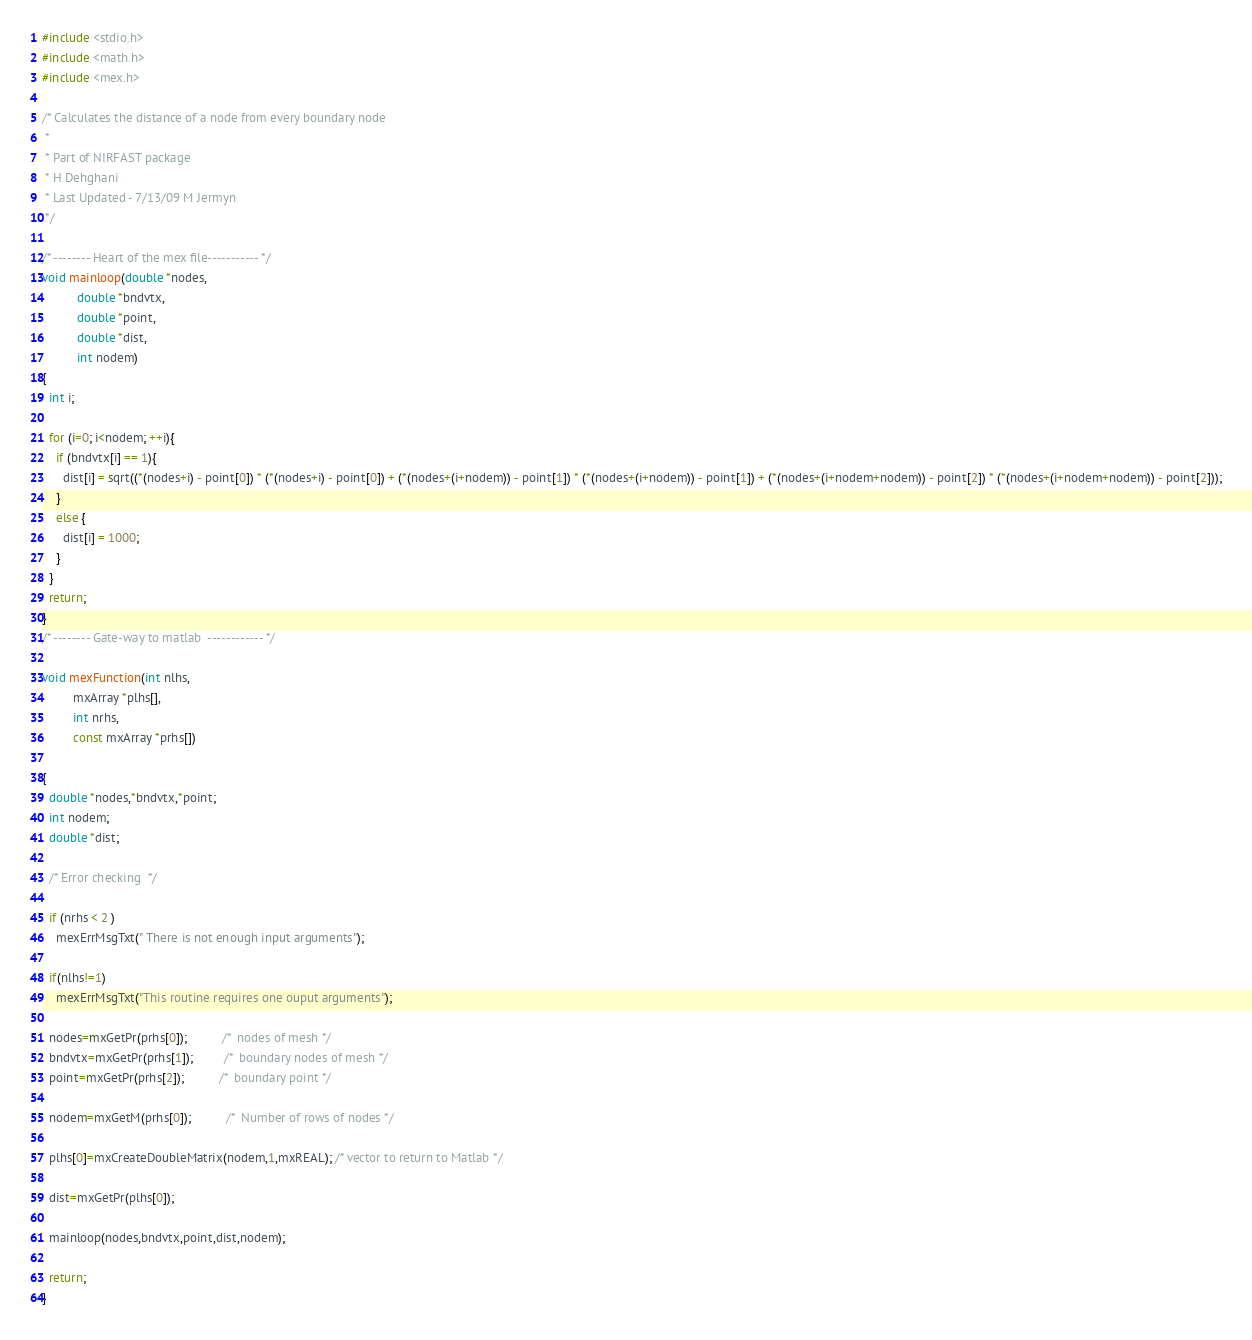Convert code to text. <code><loc_0><loc_0><loc_500><loc_500><_C_>#include <stdio.h>
#include <math.h>
#include <mex.h>

/* Calculates the distance of a node from every boundary node
 *
 * Part of NIRFAST package
 * H Dehghani
 * Last Updated - 7/13/09 M Jermyn
 */

/* -------- Heart of the mex file----------- */
void mainloop(double *nodes,
	      double *bndvtx,
	      double *point,
	      double *dist,
	      int nodem)
{
  int i; 

  for (i=0; i<nodem; ++i){
    if (bndvtx[i] == 1){
      dist[i] = sqrt((*(nodes+i) - point[0]) * (*(nodes+i) - point[0]) + (*(nodes+(i+nodem)) - point[1]) * (*(nodes+(i+nodem)) - point[1]) + (*(nodes+(i+nodem+nodem)) - point[2]) * (*(nodes+(i+nodem+nodem)) - point[2]));
    }
    else {
      dist[i] = 1000;
    }
  }
  return;
}
/* -------- Gate-way to matlab  ------------ */

void mexFunction(int nlhs,
		 mxArray *plhs[],
		 int nrhs,
		 const mxArray *prhs[])

{
  double *nodes,*bndvtx,*point;
  int nodem;
  double *dist;
  
  /* Error checking  */

  if (nrhs < 2 )
    mexErrMsgTxt(" There is not enough input arguments");
  
  if(nlhs!=1)
    mexErrMsgTxt("This routine requires one ouput arguments");
  
  nodes=mxGetPr(prhs[0]);          /*  nodes of mesh */
  bndvtx=mxGetPr(prhs[1]);         /*  boundary nodes of mesh */
  point=mxGetPr(prhs[2]);          /*  boundary point */
  
  nodem=mxGetM(prhs[0]);          /*  Number of rows of nodes */
  
  plhs[0]=mxCreateDoubleMatrix(nodem,1,mxREAL); /* vector to return to Matlab */
  
  dist=mxGetPr(plhs[0]);
  
  mainloop(nodes,bndvtx,point,dist,nodem);
  
  return;
}
</code> 